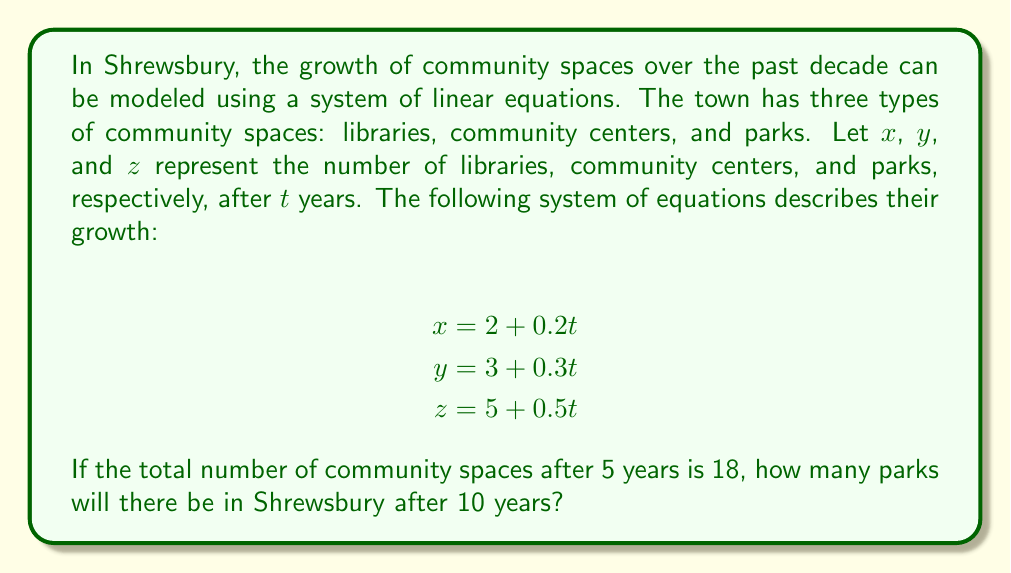What is the answer to this math problem? To solve this problem, we'll follow these steps:

1) First, let's calculate the number of each type of community space after 5 years:

   For libraries: $x = 2 + 0.2(5) = 3$
   For community centers: $y = 3 + 0.3(5) = 4.5$
   For parks: $z = 5 + 0.5(5) = 7.5$

2) We're told that the total number of spaces after 5 years is 18. Let's verify:

   $3 + 4.5 + 7.5 = 15$

   This doesn't equal 18, so we need to adjust our equations.

3) Let's introduce a correction factor $c$ to each equation:

   $$\begin{align*}
   x &= 2 + 0.2t + c \\
   y &= 3 + 0.3t + c \\
   z &= 5 + 0.5t + c
   \end{align*}$$

4) Now, we can solve for $c$ using the information about the 5-year total:

   $(2 + 0.2(5) + c) + (3 + 0.3(5) + c) + (5 + 0.5(5) + c) = 18$
   $(3 + c) + (4.5 + c) + (7.5 + c) = 18$
   $15 + 3c = 18$
   $3c = 3$
   $c = 1$

5) Our corrected equation for parks is now:

   $z = 5 + 0.5t + 1 = 6 + 0.5t$

6) To find the number of parks after 10 years, we substitute $t = 10$:

   $z = 6 + 0.5(10) = 6 + 5 = 11$

Therefore, after 10 years, there will be 11 parks in Shrewsbury.
Answer: 11 parks 